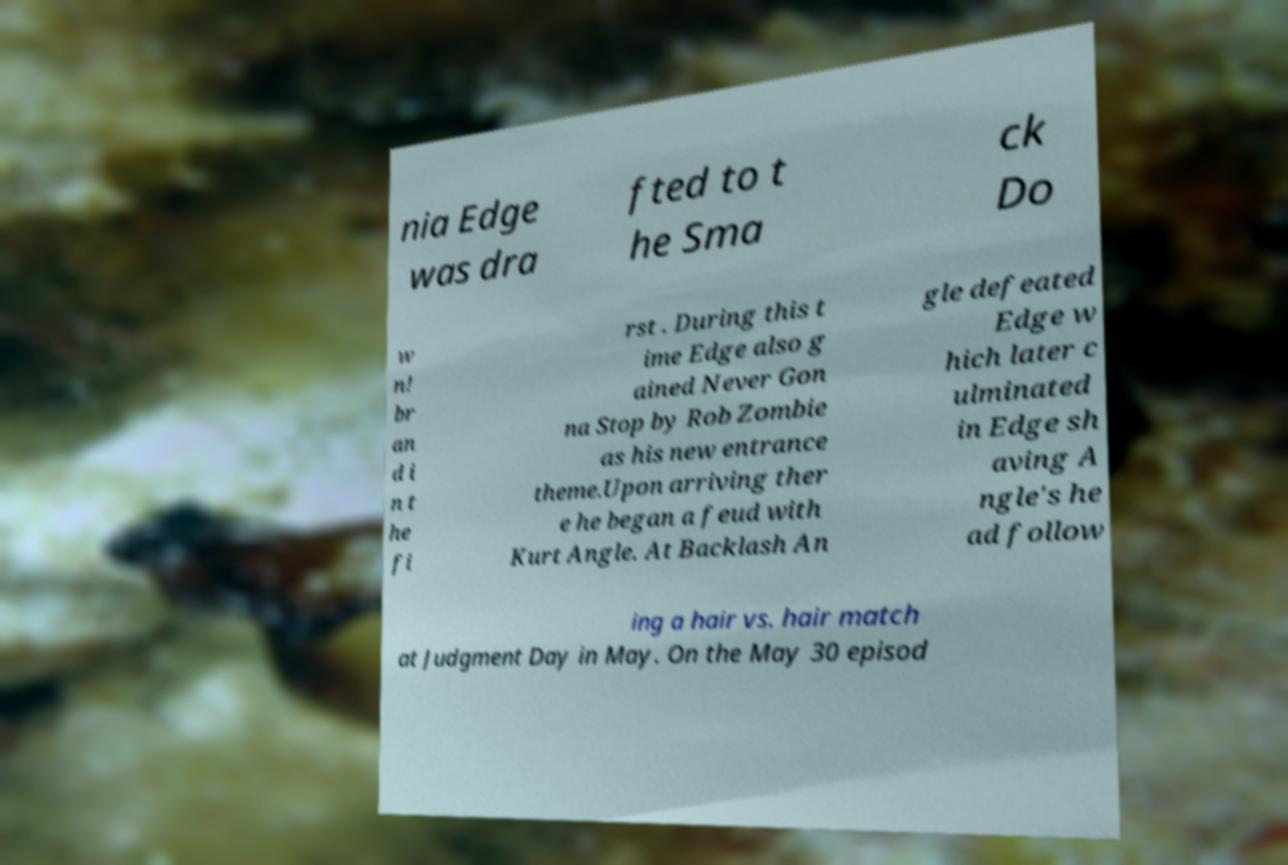Please identify and transcribe the text found in this image. nia Edge was dra fted to t he Sma ck Do w n! br an d i n t he fi rst . During this t ime Edge also g ained Never Gon na Stop by Rob Zombie as his new entrance theme.Upon arriving ther e he began a feud with Kurt Angle. At Backlash An gle defeated Edge w hich later c ulminated in Edge sh aving A ngle's he ad follow ing a hair vs. hair match at Judgment Day in May. On the May 30 episod 